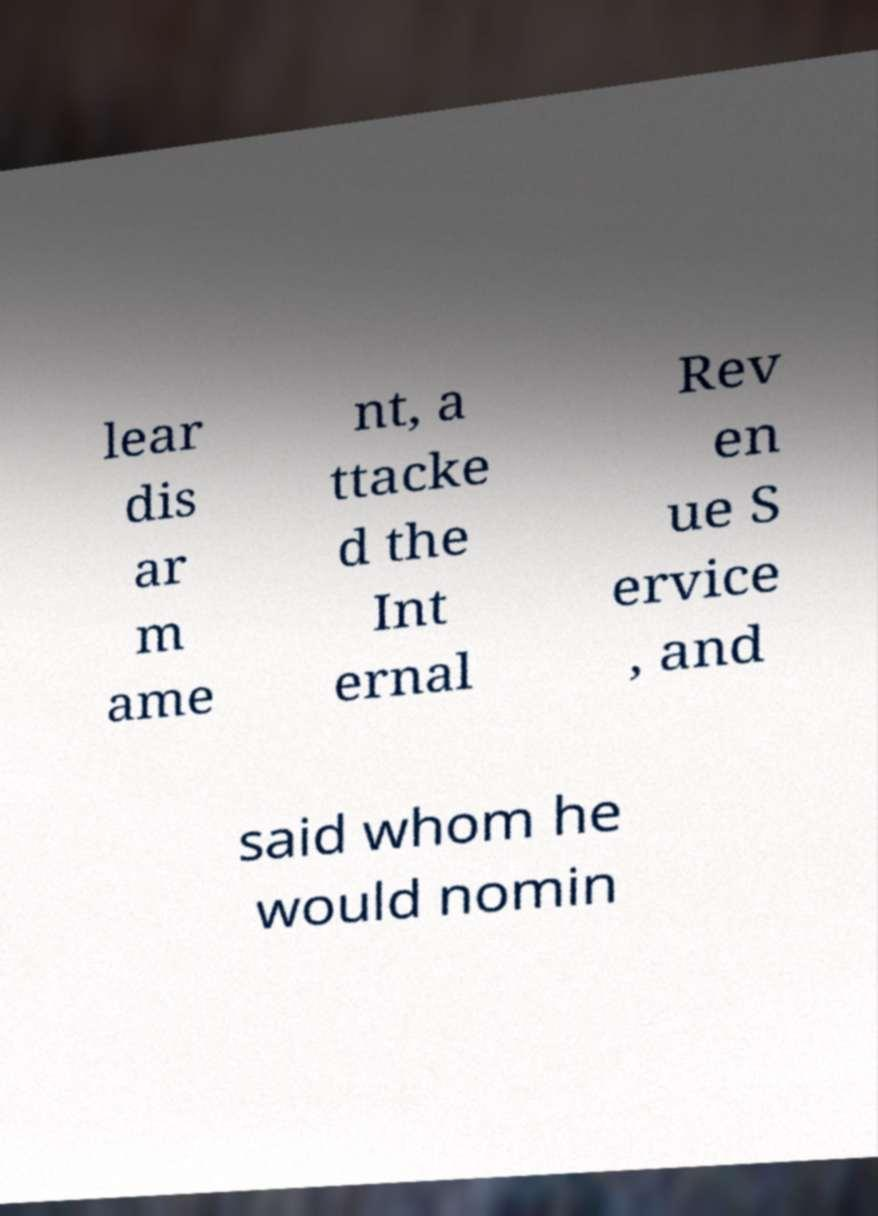I need the written content from this picture converted into text. Can you do that? lear dis ar m ame nt, a ttacke d the Int ernal Rev en ue S ervice , and said whom he would nomin 